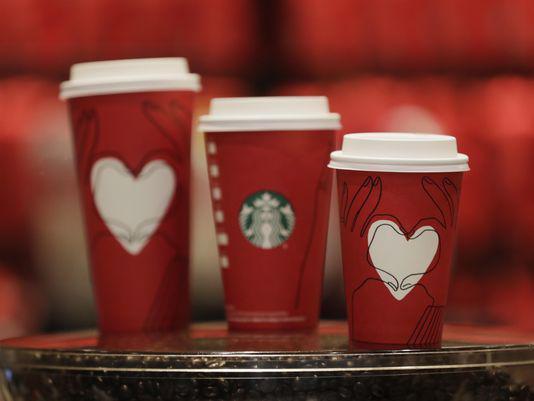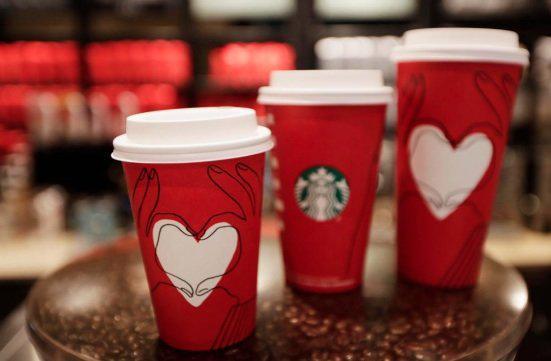The first image is the image on the left, the second image is the image on the right. For the images displayed, is the sentence "There is a single cup in one of the images." factually correct? Answer yes or no. No. The first image is the image on the left, the second image is the image on the right. For the images displayed, is the sentence "At least one image includes a white cup with a lid on it and an illustration of holding hands on its front." factually correct? Answer yes or no. No. 